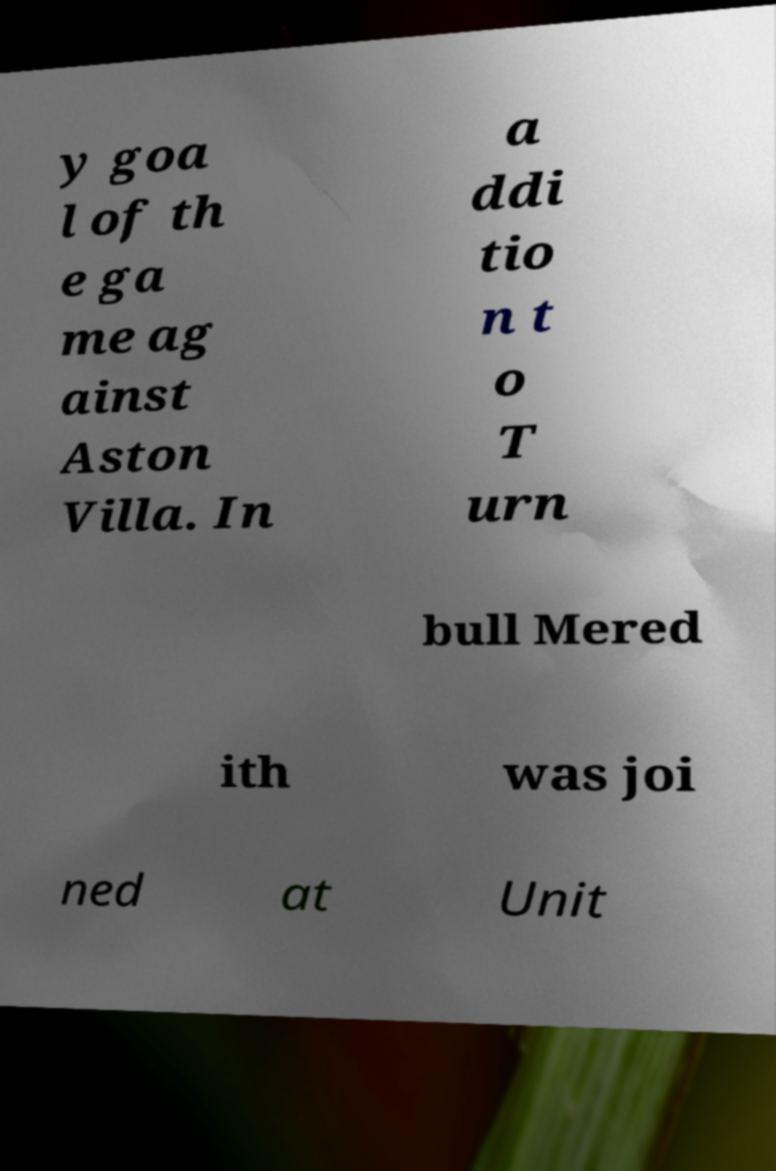What messages or text are displayed in this image? I need them in a readable, typed format. y goa l of th e ga me ag ainst Aston Villa. In a ddi tio n t o T urn bull Mered ith was joi ned at Unit 